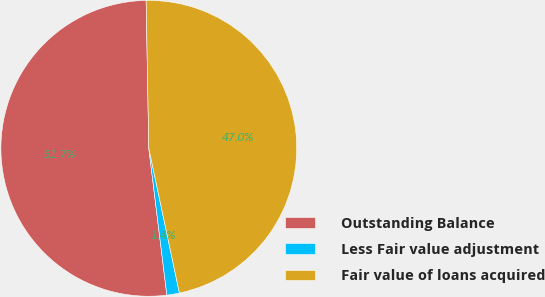Convert chart. <chart><loc_0><loc_0><loc_500><loc_500><pie_chart><fcel>Outstanding Balance<fcel>Less Fair value adjustment<fcel>Fair value of loans acquired<nl><fcel>51.66%<fcel>1.37%<fcel>46.97%<nl></chart> 